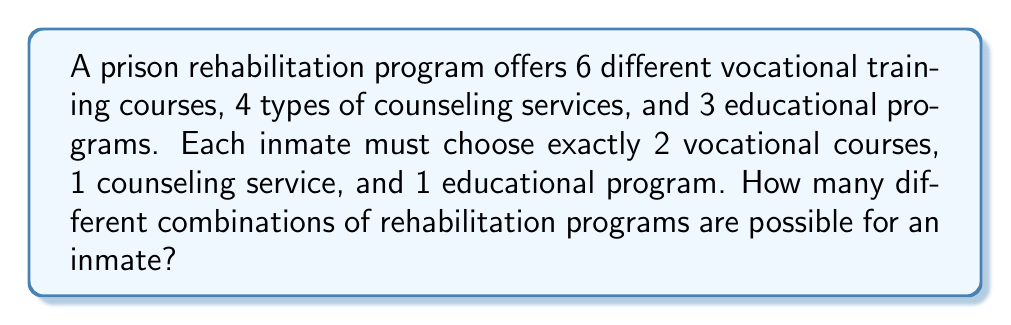Can you answer this question? To solve this problem, we need to use the multiplication principle of counting. We'll break down the problem into steps:

1. Choosing vocational courses:
   The inmate must choose 2 out of 6 vocational courses. This is a combination problem.
   Number of ways to choose vocational courses = $\binom{6}{2} = \frac{6!}{2!(6-2)!} = \frac{6 \cdot 5}{2 \cdot 1} = 15$

2. Choosing a counseling service:
   The inmate must choose 1 out of 4 counseling services.
   Number of ways to choose a counseling service = $4$

3. Choosing an educational program:
   The inmate must choose 1 out of 3 educational programs.
   Number of ways to choose an educational program = $3$

4. Applying the multiplication principle:
   To get the total number of possible combinations, we multiply the number of ways for each choice:

   Total combinations = $15 \cdot 4 \cdot 3 = 180$

Therefore, there are 180 different possible combinations of rehabilitation programs for an inmate.
Answer: 180 combinations 